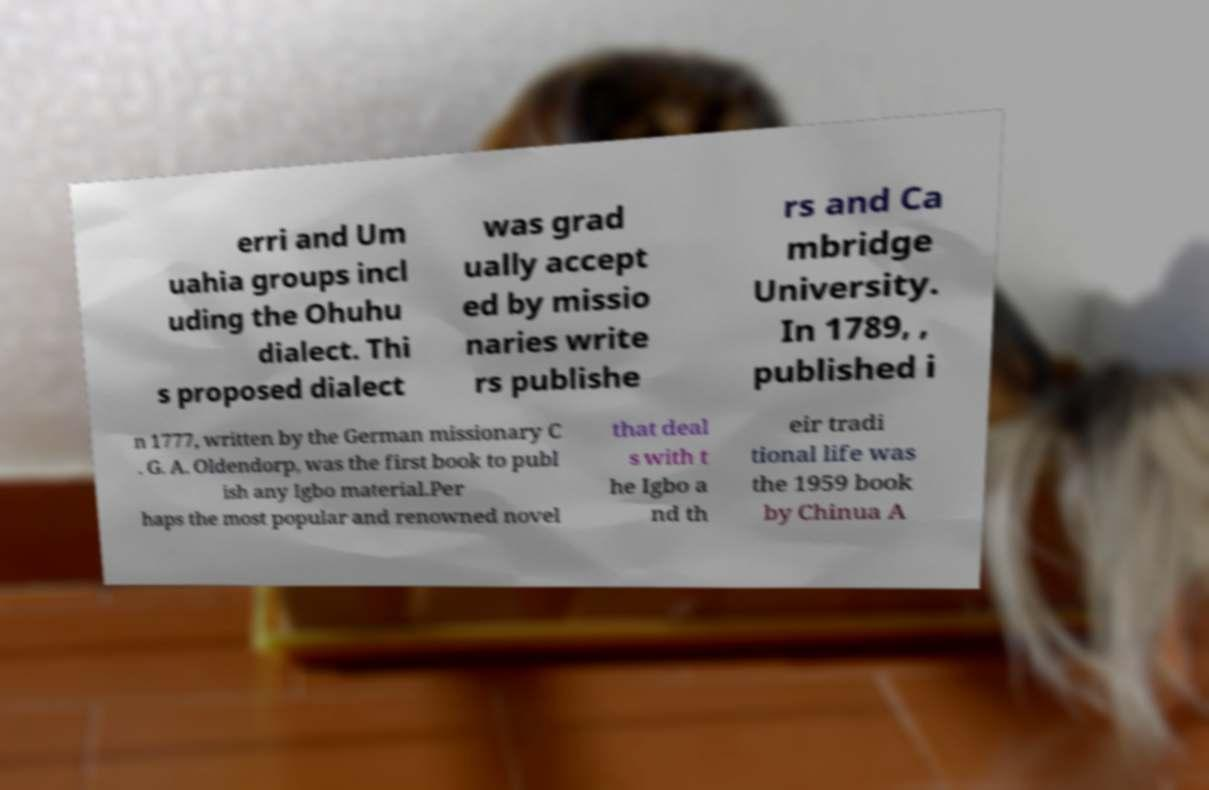Please identify and transcribe the text found in this image. erri and Um uahia groups incl uding the Ohuhu dialect. Thi s proposed dialect was grad ually accept ed by missio naries write rs publishe rs and Ca mbridge University. In 1789, , published i n 1777, written by the German missionary C . G. A. Oldendorp, was the first book to publ ish any Igbo material.Per haps the most popular and renowned novel that deal s with t he Igbo a nd th eir tradi tional life was the 1959 book by Chinua A 